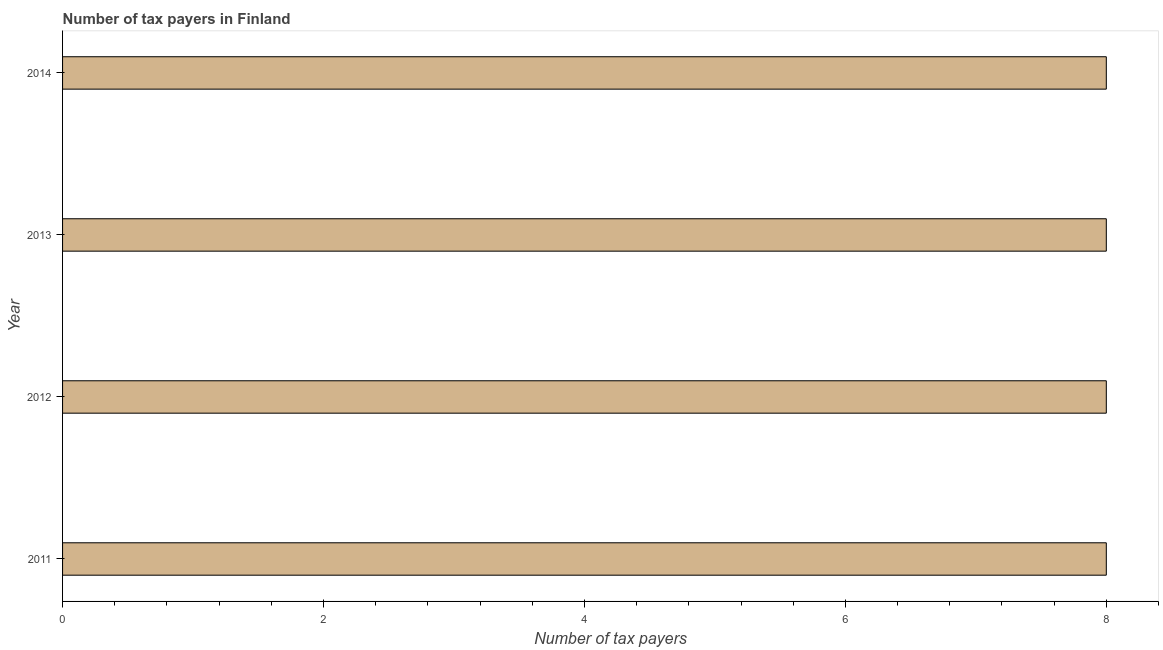What is the title of the graph?
Offer a terse response. Number of tax payers in Finland. What is the label or title of the X-axis?
Make the answer very short. Number of tax payers. What is the label or title of the Y-axis?
Keep it short and to the point. Year. What is the number of tax payers in 2012?
Ensure brevity in your answer.  8. Across all years, what is the minimum number of tax payers?
Give a very brief answer. 8. In which year was the number of tax payers maximum?
Make the answer very short. 2011. In which year was the number of tax payers minimum?
Ensure brevity in your answer.  2011. What is the sum of the number of tax payers?
Your answer should be very brief. 32. What is the difference between the number of tax payers in 2012 and 2014?
Make the answer very short. 0. In how many years, is the number of tax payers greater than 3.6 ?
Keep it short and to the point. 4. What is the ratio of the number of tax payers in 2011 to that in 2014?
Ensure brevity in your answer.  1. Is the number of tax payers in 2012 less than that in 2014?
Offer a terse response. No. Are all the bars in the graph horizontal?
Offer a very short reply. Yes. What is the Number of tax payers of 2011?
Ensure brevity in your answer.  8. What is the Number of tax payers of 2012?
Provide a short and direct response. 8. What is the difference between the Number of tax payers in 2011 and 2012?
Offer a terse response. 0. What is the difference between the Number of tax payers in 2011 and 2013?
Ensure brevity in your answer.  0. What is the difference between the Number of tax payers in 2011 and 2014?
Your answer should be very brief. 0. What is the difference between the Number of tax payers in 2013 and 2014?
Make the answer very short. 0. What is the ratio of the Number of tax payers in 2011 to that in 2012?
Offer a very short reply. 1. What is the ratio of the Number of tax payers in 2012 to that in 2013?
Your response must be concise. 1. What is the ratio of the Number of tax payers in 2012 to that in 2014?
Make the answer very short. 1. What is the ratio of the Number of tax payers in 2013 to that in 2014?
Make the answer very short. 1. 